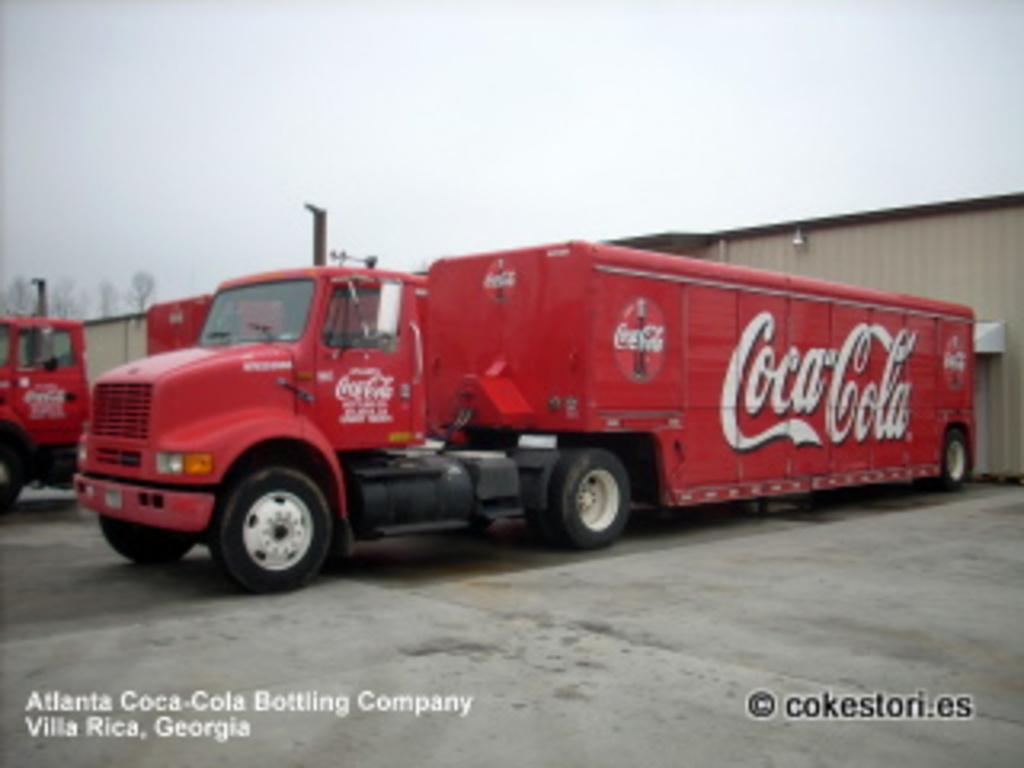What type of vehicles are in the image? There are trucks in the image. Where are the trucks located in relation to other structures? The trucks are in front of a shed. What is visible at the top of the image? The sky is visible at the top of the image. How many cherries are hanging from the trucks in the image? There are no cherries present in the image; it features trucks in front of a shed. What is the yard like in the image? There is no yard mentioned in the image; it only describes trucks in front of a shed and the visible sky. 